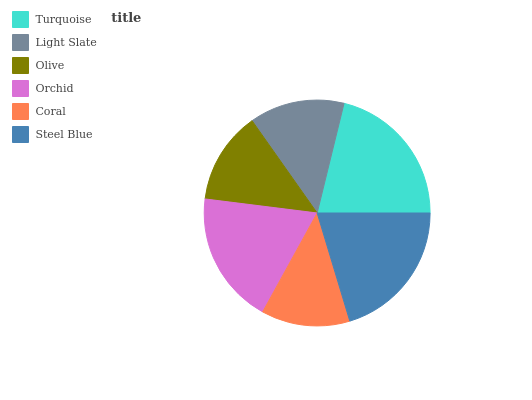Is Coral the minimum?
Answer yes or no. Yes. Is Turquoise the maximum?
Answer yes or no. Yes. Is Light Slate the minimum?
Answer yes or no. No. Is Light Slate the maximum?
Answer yes or no. No. Is Turquoise greater than Light Slate?
Answer yes or no. Yes. Is Light Slate less than Turquoise?
Answer yes or no. Yes. Is Light Slate greater than Turquoise?
Answer yes or no. No. Is Turquoise less than Light Slate?
Answer yes or no. No. Is Orchid the high median?
Answer yes or no. Yes. Is Light Slate the low median?
Answer yes or no. Yes. Is Light Slate the high median?
Answer yes or no. No. Is Coral the low median?
Answer yes or no. No. 